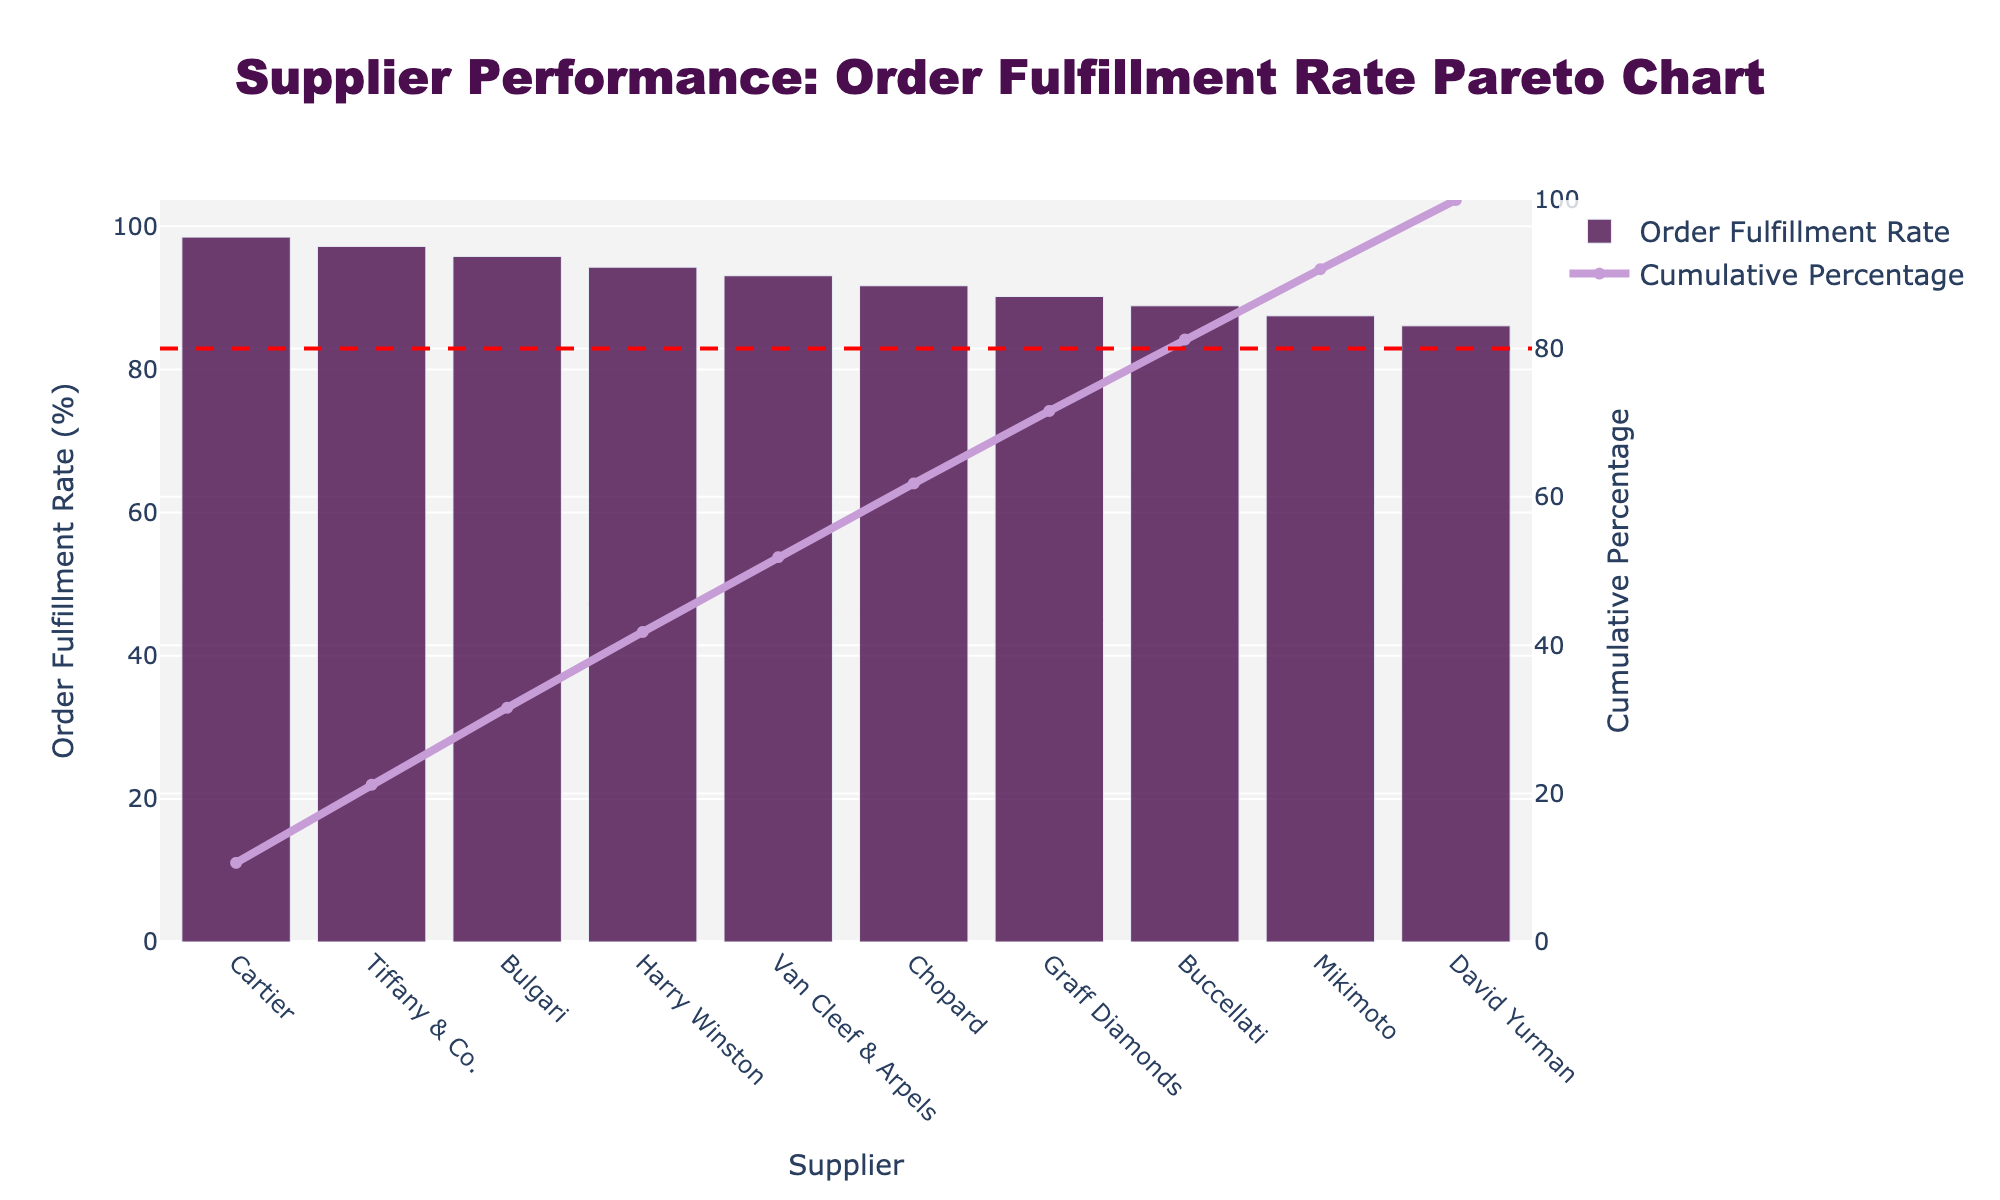What's the title of this Pareto chart? The title is visible at the top-center of the chart, stating the main focus of the analysis.
Answer: Supplier Performance: Order Fulfillment Rate Pareto Chart Which supplier has the highest order fulfillment rate? The highest bar represents the supplier with the highest order fulfillment rate on the x-axis.
Answer: Cartier What is the order fulfillment rate for David Yurman? Locate David Yurman on the x-axis and check the corresponding bar's height on the y-axis.
Answer: 86.1% How many suppliers have an order fulfillment rate above 90%? Count the number of bars with heights above the 90% mark on the y-axis.
Answer: 7 Which supplier ranks third in terms of order fulfillment rate? Identify the third tallest bar from the left and check the supplier name on the x-axis.
Answer: Bulgari What is the cumulative percentage after Chopard? Identify the last point for the cumulative line on Chopard, the y-value on the secondary y-axis shows the cumulative percentage.
Answer: 77% By which supplier does the cumulative percentage cross 80%? Look along the cumulative percentage line to find where it first meets or exceeds 80%, and note the corresponding supplier on the x-axis.
Answer: Graff Diamonds Which supplier has the lowest order fulfillment rate? The shortest bar represents the supplier with the lowest order fulfillment rate on the x-axis.
Answer: David Yurman How does the order fulfillment rate for Van Cleef & Arpels compare to Tiffany & Co.? Compare the heights of the bars for the two suppliers on the y-axis. Van Cleef & Arpels' bar is lower than Tiffany & Co.'s.
Answer: Van Cleef & Arpels is lower What is the total cumulative percentage covered by the top two suppliers? Add the cumulative percentages of Cartier and Tiffany & Co. as indicated by the line graph on the secondary y-axis.
Answer: 50.3% 